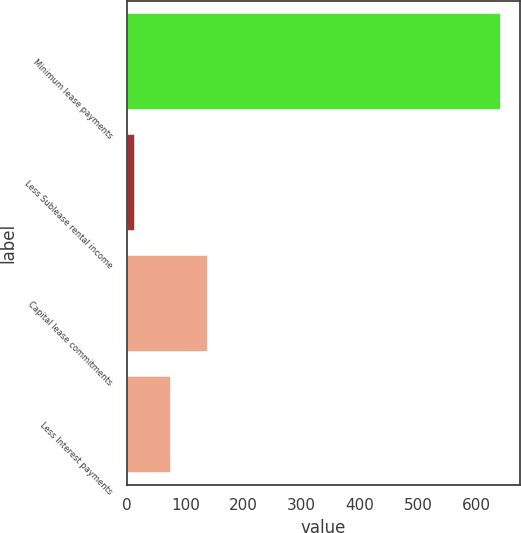Convert chart. <chart><loc_0><loc_0><loc_500><loc_500><bar_chart><fcel>Minimum lease payments<fcel>Less Sublease rental income<fcel>Capital lease commitments<fcel>Less Interest payments<nl><fcel>643<fcel>13<fcel>139<fcel>76<nl></chart> 